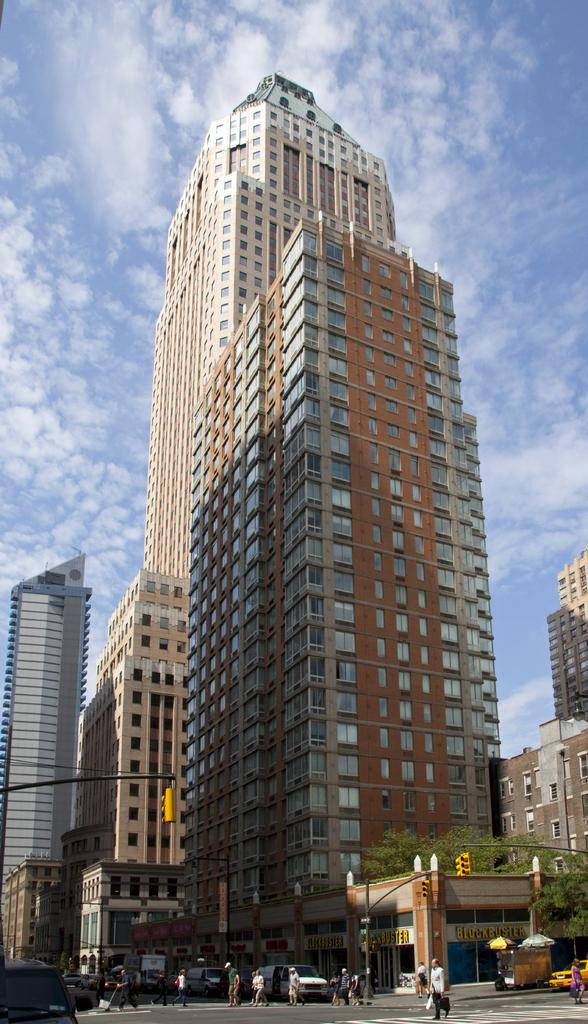What are the people in the image doing? There are persons walking in the center of the image. What else can be seen in the image besides the people? There are vehicles on the road in the image. What is visible in the background of the image? There are buildings in the background of the image. How would you describe the weather in the image? The sky is cloudy in the image. What type of apparatus can be seen in the hands of the persons walking in the image? There is no apparatus visible in the hands of the persons walking in the image. How many oranges are present in the image? There are no oranges present in the image. 